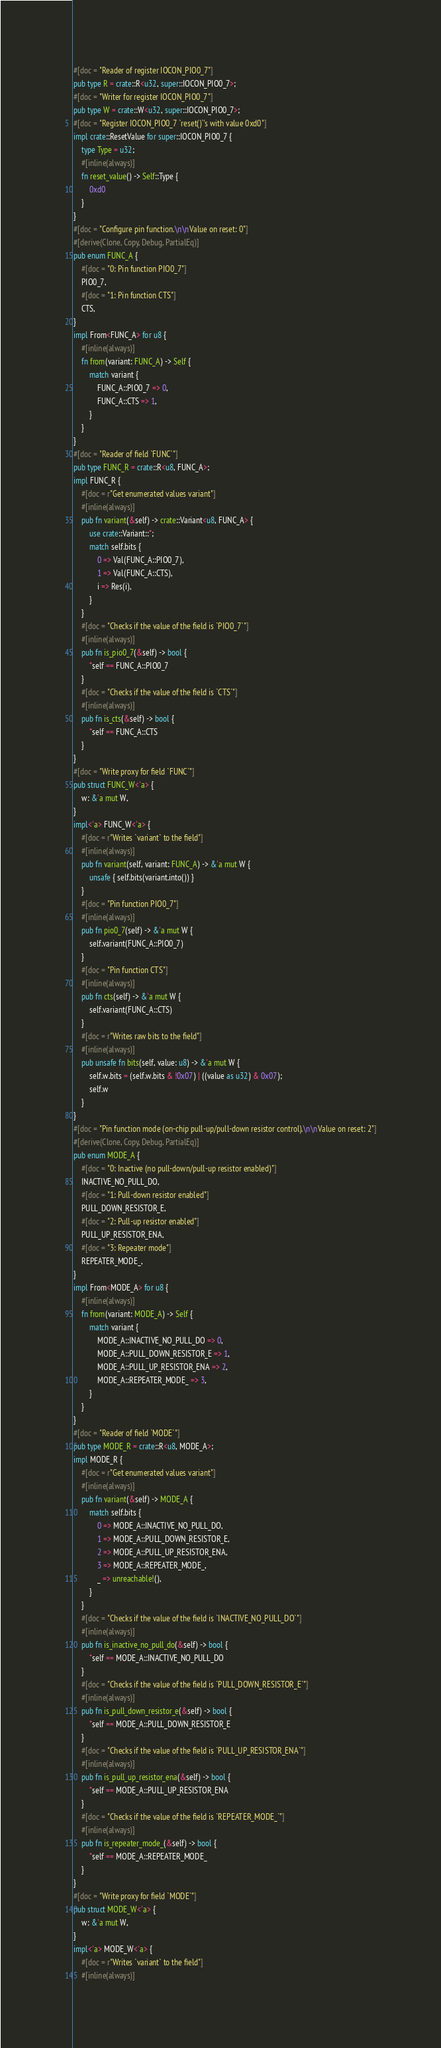Convert code to text. <code><loc_0><loc_0><loc_500><loc_500><_Rust_>#[doc = "Reader of register IOCON_PIO0_7"]
pub type R = crate::R<u32, super::IOCON_PIO0_7>;
#[doc = "Writer for register IOCON_PIO0_7"]
pub type W = crate::W<u32, super::IOCON_PIO0_7>;
#[doc = "Register IOCON_PIO0_7 `reset()`'s with value 0xd0"]
impl crate::ResetValue for super::IOCON_PIO0_7 {
    type Type = u32;
    #[inline(always)]
    fn reset_value() -> Self::Type {
        0xd0
    }
}
#[doc = "Configure pin function.\n\nValue on reset: 0"]
#[derive(Clone, Copy, Debug, PartialEq)]
pub enum FUNC_A {
    #[doc = "0: Pin function PIO0_7"]
    PIO0_7,
    #[doc = "1: Pin function CTS"]
    CTS,
}
impl From<FUNC_A> for u8 {
    #[inline(always)]
    fn from(variant: FUNC_A) -> Self {
        match variant {
            FUNC_A::PIO0_7 => 0,
            FUNC_A::CTS => 1,
        }
    }
}
#[doc = "Reader of field `FUNC`"]
pub type FUNC_R = crate::R<u8, FUNC_A>;
impl FUNC_R {
    #[doc = r"Get enumerated values variant"]
    #[inline(always)]
    pub fn variant(&self) -> crate::Variant<u8, FUNC_A> {
        use crate::Variant::*;
        match self.bits {
            0 => Val(FUNC_A::PIO0_7),
            1 => Val(FUNC_A::CTS),
            i => Res(i),
        }
    }
    #[doc = "Checks if the value of the field is `PIO0_7`"]
    #[inline(always)]
    pub fn is_pio0_7(&self) -> bool {
        *self == FUNC_A::PIO0_7
    }
    #[doc = "Checks if the value of the field is `CTS`"]
    #[inline(always)]
    pub fn is_cts(&self) -> bool {
        *self == FUNC_A::CTS
    }
}
#[doc = "Write proxy for field `FUNC`"]
pub struct FUNC_W<'a> {
    w: &'a mut W,
}
impl<'a> FUNC_W<'a> {
    #[doc = r"Writes `variant` to the field"]
    #[inline(always)]
    pub fn variant(self, variant: FUNC_A) -> &'a mut W {
        unsafe { self.bits(variant.into()) }
    }
    #[doc = "Pin function PIO0_7"]
    #[inline(always)]
    pub fn pio0_7(self) -> &'a mut W {
        self.variant(FUNC_A::PIO0_7)
    }
    #[doc = "Pin function CTS"]
    #[inline(always)]
    pub fn cts(self) -> &'a mut W {
        self.variant(FUNC_A::CTS)
    }
    #[doc = r"Writes raw bits to the field"]
    #[inline(always)]
    pub unsafe fn bits(self, value: u8) -> &'a mut W {
        self.w.bits = (self.w.bits & !0x07) | ((value as u32) & 0x07);
        self.w
    }
}
#[doc = "Pin function mode (on-chip pull-up/pull-down resistor control).\n\nValue on reset: 2"]
#[derive(Clone, Copy, Debug, PartialEq)]
pub enum MODE_A {
    #[doc = "0: Inactive (no pull-down/pull-up resistor enabled)"]
    INACTIVE_NO_PULL_DO,
    #[doc = "1: Pull-down resistor enabled"]
    PULL_DOWN_RESISTOR_E,
    #[doc = "2: Pull-up resistor enabled"]
    PULL_UP_RESISTOR_ENA,
    #[doc = "3: Repeater mode"]
    REPEATER_MODE_,
}
impl From<MODE_A> for u8 {
    #[inline(always)]
    fn from(variant: MODE_A) -> Self {
        match variant {
            MODE_A::INACTIVE_NO_PULL_DO => 0,
            MODE_A::PULL_DOWN_RESISTOR_E => 1,
            MODE_A::PULL_UP_RESISTOR_ENA => 2,
            MODE_A::REPEATER_MODE_ => 3,
        }
    }
}
#[doc = "Reader of field `MODE`"]
pub type MODE_R = crate::R<u8, MODE_A>;
impl MODE_R {
    #[doc = r"Get enumerated values variant"]
    #[inline(always)]
    pub fn variant(&self) -> MODE_A {
        match self.bits {
            0 => MODE_A::INACTIVE_NO_PULL_DO,
            1 => MODE_A::PULL_DOWN_RESISTOR_E,
            2 => MODE_A::PULL_UP_RESISTOR_ENA,
            3 => MODE_A::REPEATER_MODE_,
            _ => unreachable!(),
        }
    }
    #[doc = "Checks if the value of the field is `INACTIVE_NO_PULL_DO`"]
    #[inline(always)]
    pub fn is_inactive_no_pull_do(&self) -> bool {
        *self == MODE_A::INACTIVE_NO_PULL_DO
    }
    #[doc = "Checks if the value of the field is `PULL_DOWN_RESISTOR_E`"]
    #[inline(always)]
    pub fn is_pull_down_resistor_e(&self) -> bool {
        *self == MODE_A::PULL_DOWN_RESISTOR_E
    }
    #[doc = "Checks if the value of the field is `PULL_UP_RESISTOR_ENA`"]
    #[inline(always)]
    pub fn is_pull_up_resistor_ena(&self) -> bool {
        *self == MODE_A::PULL_UP_RESISTOR_ENA
    }
    #[doc = "Checks if the value of the field is `REPEATER_MODE_`"]
    #[inline(always)]
    pub fn is_repeater_mode_(&self) -> bool {
        *self == MODE_A::REPEATER_MODE_
    }
}
#[doc = "Write proxy for field `MODE`"]
pub struct MODE_W<'a> {
    w: &'a mut W,
}
impl<'a> MODE_W<'a> {
    #[doc = r"Writes `variant` to the field"]
    #[inline(always)]</code> 